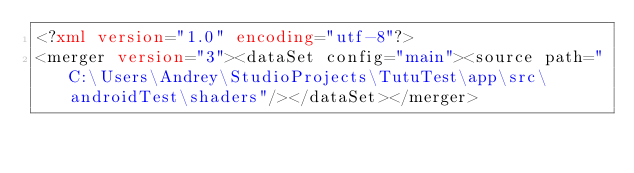<code> <loc_0><loc_0><loc_500><loc_500><_XML_><?xml version="1.0" encoding="utf-8"?>
<merger version="3"><dataSet config="main"><source path="C:\Users\Andrey\StudioProjects\TutuTest\app\src\androidTest\shaders"/></dataSet></merger></code> 